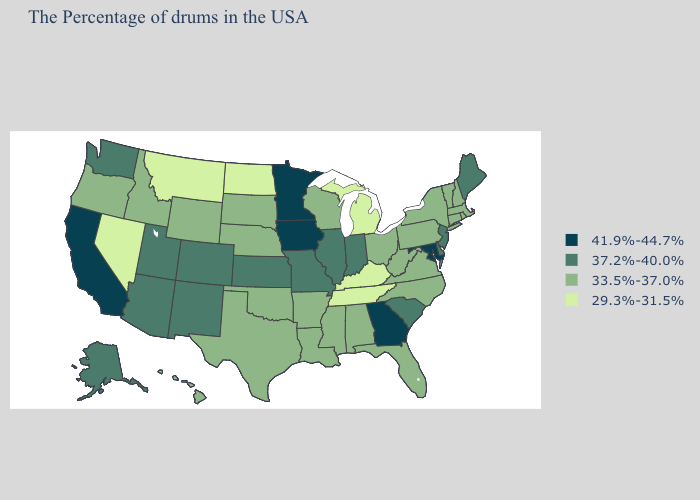Does Connecticut have the highest value in the Northeast?
Give a very brief answer. No. Name the states that have a value in the range 33.5%-37.0%?
Quick response, please. Massachusetts, Rhode Island, New Hampshire, Vermont, Connecticut, New York, Pennsylvania, Virginia, North Carolina, West Virginia, Ohio, Florida, Alabama, Wisconsin, Mississippi, Louisiana, Arkansas, Nebraska, Oklahoma, Texas, South Dakota, Wyoming, Idaho, Oregon, Hawaii. Name the states that have a value in the range 41.9%-44.7%?
Short answer required. Maryland, Georgia, Minnesota, Iowa, California. Among the states that border New York , which have the lowest value?
Short answer required. Massachusetts, Vermont, Connecticut, Pennsylvania. Does the map have missing data?
Keep it brief. No. Does the map have missing data?
Answer briefly. No. Does Ohio have the same value as Oklahoma?
Write a very short answer. Yes. What is the value of Georgia?
Be succinct. 41.9%-44.7%. Name the states that have a value in the range 29.3%-31.5%?
Write a very short answer. Michigan, Kentucky, Tennessee, North Dakota, Montana, Nevada. Does New Jersey have the lowest value in the Northeast?
Write a very short answer. No. Does Tennessee have the lowest value in the USA?
Write a very short answer. Yes. Name the states that have a value in the range 33.5%-37.0%?
Be succinct. Massachusetts, Rhode Island, New Hampshire, Vermont, Connecticut, New York, Pennsylvania, Virginia, North Carolina, West Virginia, Ohio, Florida, Alabama, Wisconsin, Mississippi, Louisiana, Arkansas, Nebraska, Oklahoma, Texas, South Dakota, Wyoming, Idaho, Oregon, Hawaii. What is the value of Nevada?
Quick response, please. 29.3%-31.5%. Name the states that have a value in the range 37.2%-40.0%?
Answer briefly. Maine, New Jersey, Delaware, South Carolina, Indiana, Illinois, Missouri, Kansas, Colorado, New Mexico, Utah, Arizona, Washington, Alaska. Which states have the lowest value in the USA?
Write a very short answer. Michigan, Kentucky, Tennessee, North Dakota, Montana, Nevada. 